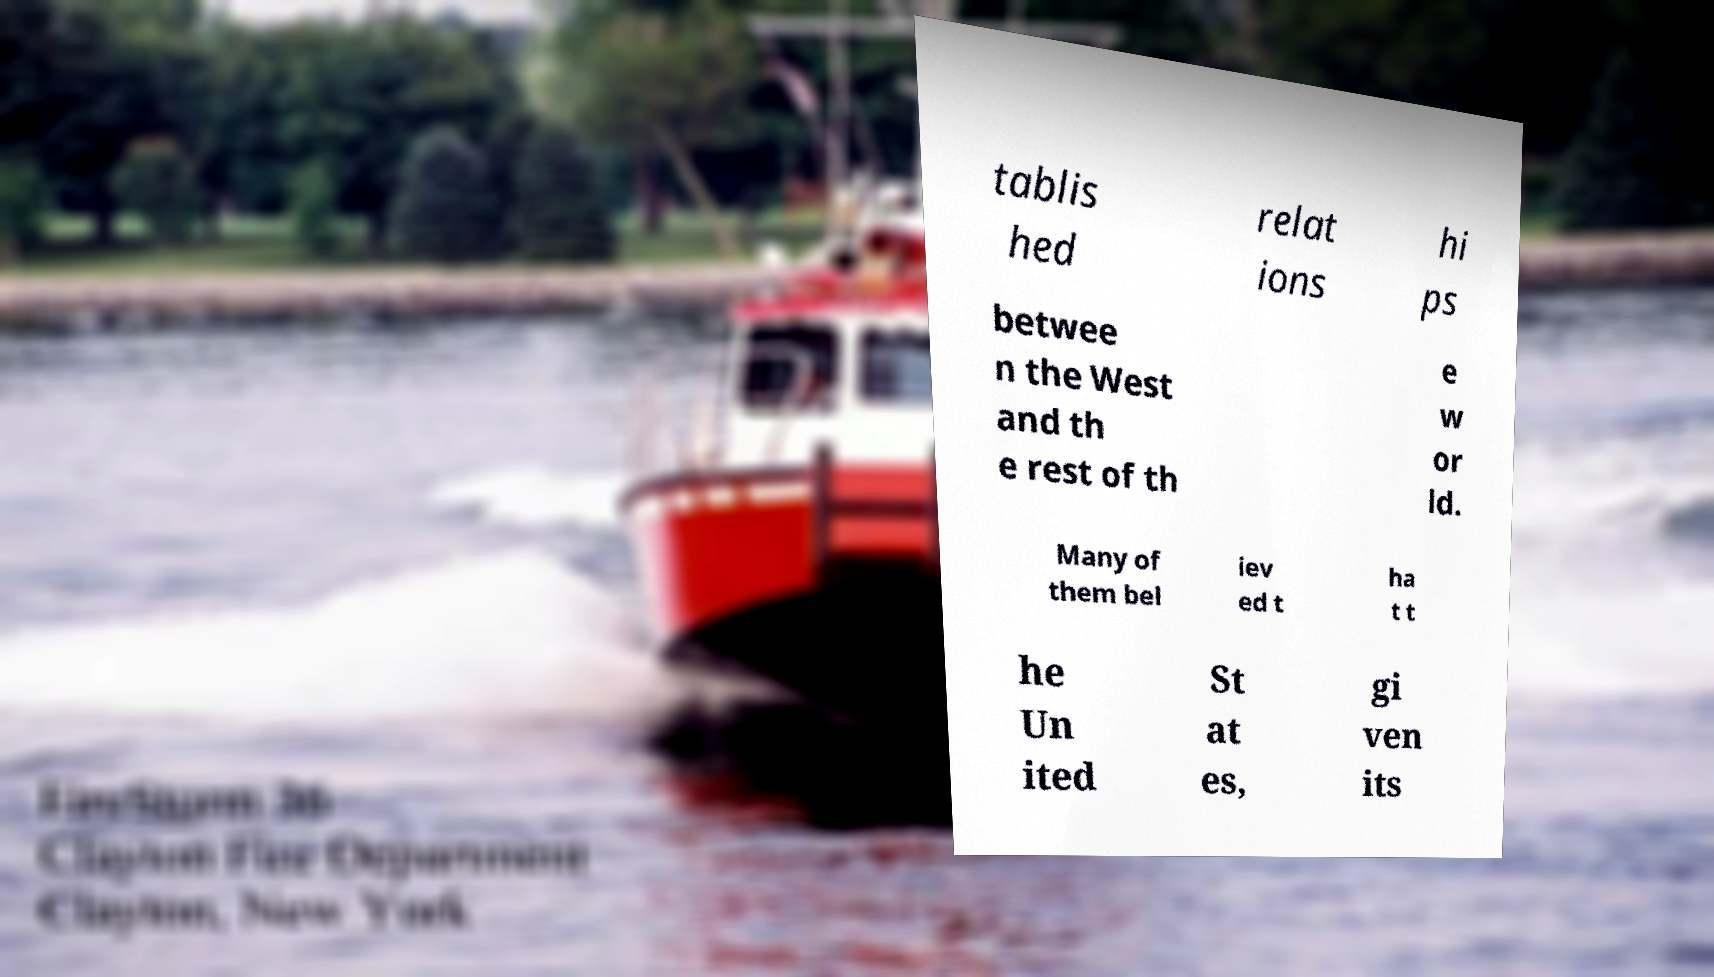I need the written content from this picture converted into text. Can you do that? tablis hed relat ions hi ps betwee n the West and th e rest of th e w or ld. Many of them bel iev ed t ha t t he Un ited St at es, gi ven its 